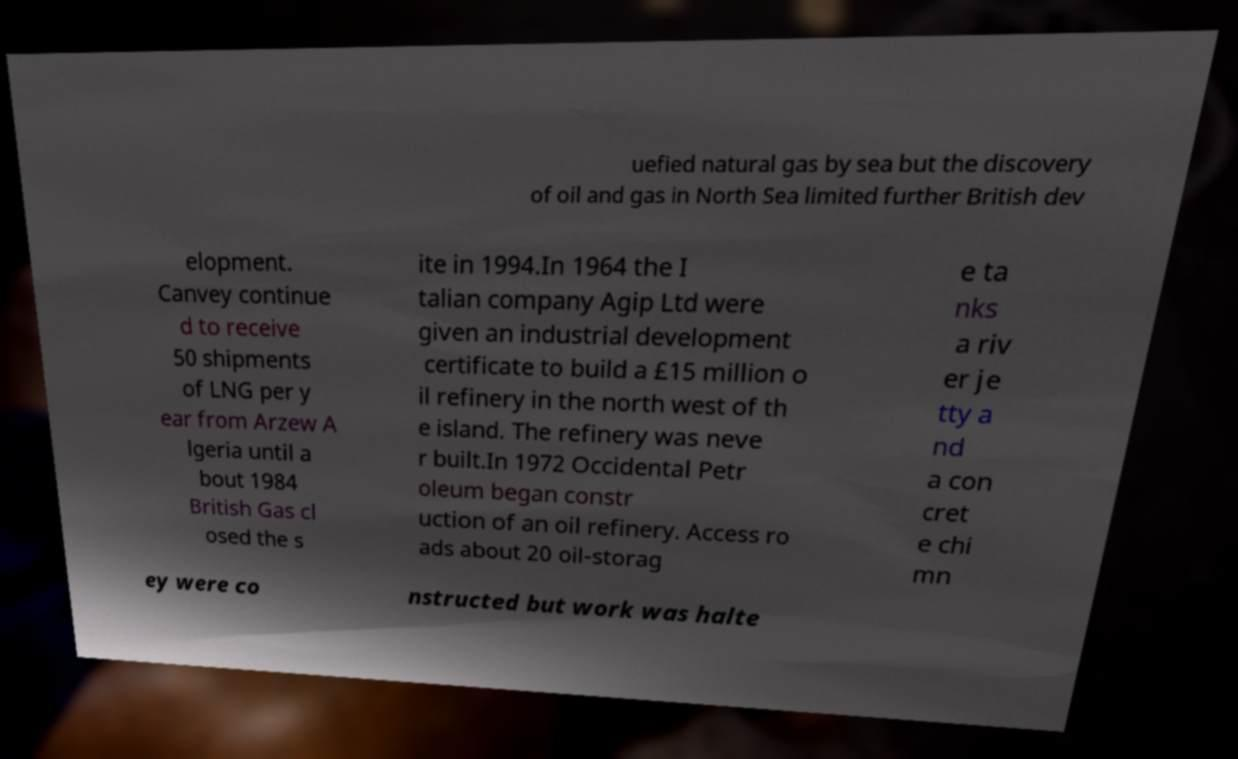Could you extract and type out the text from this image? uefied natural gas by sea but the discovery of oil and gas in North Sea limited further British dev elopment. Canvey continue d to receive 50 shipments of LNG per y ear from Arzew A lgeria until a bout 1984 British Gas cl osed the s ite in 1994.In 1964 the I talian company Agip Ltd were given an industrial development certificate to build a £15 million o il refinery in the north west of th e island. The refinery was neve r built.In 1972 Occidental Petr oleum began constr uction of an oil refinery. Access ro ads about 20 oil-storag e ta nks a riv er je tty a nd a con cret e chi mn ey were co nstructed but work was halte 